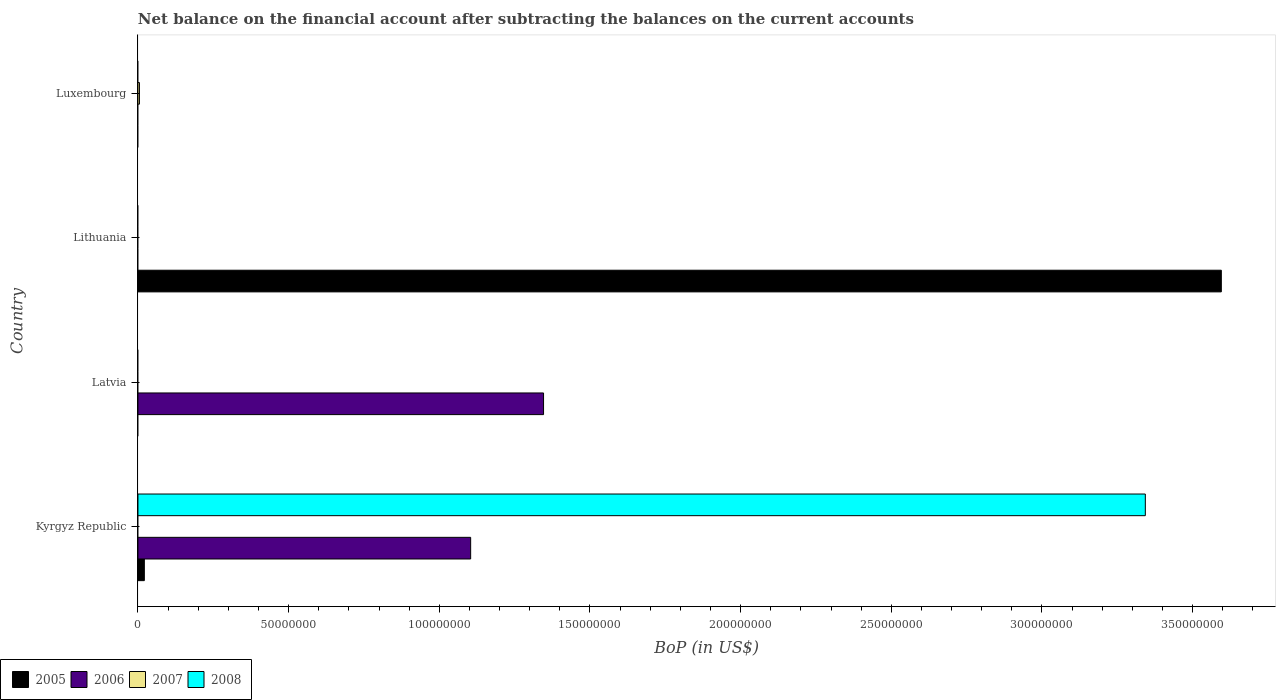How many different coloured bars are there?
Ensure brevity in your answer.  4. Are the number of bars per tick equal to the number of legend labels?
Your answer should be compact. No. How many bars are there on the 3rd tick from the top?
Provide a short and direct response. 1. How many bars are there on the 2nd tick from the bottom?
Make the answer very short. 1. What is the label of the 1st group of bars from the top?
Your answer should be compact. Luxembourg. What is the Balance of Payments in 2008 in Kyrgyz Republic?
Give a very brief answer. 3.34e+08. Across all countries, what is the maximum Balance of Payments in 2008?
Your answer should be compact. 3.34e+08. Across all countries, what is the minimum Balance of Payments in 2006?
Offer a very short reply. 0. In which country was the Balance of Payments in 2005 maximum?
Make the answer very short. Lithuania. What is the total Balance of Payments in 2006 in the graph?
Offer a very short reply. 2.45e+08. What is the difference between the Balance of Payments in 2005 in Kyrgyz Republic and that in Lithuania?
Keep it short and to the point. -3.57e+08. What is the difference between the Balance of Payments in 2008 in Luxembourg and the Balance of Payments in 2005 in Latvia?
Make the answer very short. 0. What is the average Balance of Payments in 2006 per country?
Provide a short and direct response. 6.13e+07. What is the difference between the highest and the lowest Balance of Payments in 2007?
Provide a succinct answer. 4.90e+05. Is it the case that in every country, the sum of the Balance of Payments in 2005 and Balance of Payments in 2008 is greater than the sum of Balance of Payments in 2006 and Balance of Payments in 2007?
Your answer should be very brief. No. How many bars are there?
Ensure brevity in your answer.  6. Are all the bars in the graph horizontal?
Provide a succinct answer. Yes. What is the difference between two consecutive major ticks on the X-axis?
Keep it short and to the point. 5.00e+07. Does the graph contain any zero values?
Keep it short and to the point. Yes. Where does the legend appear in the graph?
Ensure brevity in your answer.  Bottom left. How many legend labels are there?
Your response must be concise. 4. What is the title of the graph?
Offer a terse response. Net balance on the financial account after subtracting the balances on the current accounts. What is the label or title of the X-axis?
Ensure brevity in your answer.  BoP (in US$). What is the label or title of the Y-axis?
Provide a succinct answer. Country. What is the BoP (in US$) in 2005 in Kyrgyz Republic?
Offer a very short reply. 2.12e+06. What is the BoP (in US$) in 2006 in Kyrgyz Republic?
Make the answer very short. 1.10e+08. What is the BoP (in US$) in 2008 in Kyrgyz Republic?
Your response must be concise. 3.34e+08. What is the BoP (in US$) of 2005 in Latvia?
Keep it short and to the point. 0. What is the BoP (in US$) of 2006 in Latvia?
Offer a very short reply. 1.35e+08. What is the BoP (in US$) of 2008 in Latvia?
Your answer should be very brief. 0. What is the BoP (in US$) in 2005 in Lithuania?
Keep it short and to the point. 3.60e+08. What is the BoP (in US$) of 2008 in Lithuania?
Keep it short and to the point. 0. What is the BoP (in US$) in 2005 in Luxembourg?
Your answer should be very brief. 0. What is the BoP (in US$) in 2007 in Luxembourg?
Offer a terse response. 4.90e+05. What is the BoP (in US$) of 2008 in Luxembourg?
Make the answer very short. 0. Across all countries, what is the maximum BoP (in US$) in 2005?
Your answer should be compact. 3.60e+08. Across all countries, what is the maximum BoP (in US$) in 2006?
Provide a short and direct response. 1.35e+08. Across all countries, what is the maximum BoP (in US$) in 2007?
Your answer should be compact. 4.90e+05. Across all countries, what is the maximum BoP (in US$) in 2008?
Offer a very short reply. 3.34e+08. Across all countries, what is the minimum BoP (in US$) of 2006?
Offer a very short reply. 0. Across all countries, what is the minimum BoP (in US$) in 2008?
Your answer should be very brief. 0. What is the total BoP (in US$) of 2005 in the graph?
Give a very brief answer. 3.62e+08. What is the total BoP (in US$) of 2006 in the graph?
Ensure brevity in your answer.  2.45e+08. What is the total BoP (in US$) of 2007 in the graph?
Offer a very short reply. 4.90e+05. What is the total BoP (in US$) of 2008 in the graph?
Give a very brief answer. 3.34e+08. What is the difference between the BoP (in US$) in 2006 in Kyrgyz Republic and that in Latvia?
Your answer should be very brief. -2.42e+07. What is the difference between the BoP (in US$) of 2005 in Kyrgyz Republic and that in Lithuania?
Give a very brief answer. -3.57e+08. What is the difference between the BoP (in US$) in 2005 in Kyrgyz Republic and the BoP (in US$) in 2006 in Latvia?
Give a very brief answer. -1.32e+08. What is the difference between the BoP (in US$) in 2005 in Kyrgyz Republic and the BoP (in US$) in 2007 in Luxembourg?
Make the answer very short. 1.63e+06. What is the difference between the BoP (in US$) in 2006 in Kyrgyz Republic and the BoP (in US$) in 2007 in Luxembourg?
Provide a short and direct response. 1.10e+08. What is the difference between the BoP (in US$) of 2006 in Latvia and the BoP (in US$) of 2007 in Luxembourg?
Your response must be concise. 1.34e+08. What is the difference between the BoP (in US$) of 2005 in Lithuania and the BoP (in US$) of 2007 in Luxembourg?
Your answer should be compact. 3.59e+08. What is the average BoP (in US$) of 2005 per country?
Make the answer very short. 9.04e+07. What is the average BoP (in US$) in 2006 per country?
Your response must be concise. 6.13e+07. What is the average BoP (in US$) of 2007 per country?
Offer a terse response. 1.23e+05. What is the average BoP (in US$) of 2008 per country?
Keep it short and to the point. 8.36e+07. What is the difference between the BoP (in US$) of 2005 and BoP (in US$) of 2006 in Kyrgyz Republic?
Offer a terse response. -1.08e+08. What is the difference between the BoP (in US$) of 2005 and BoP (in US$) of 2008 in Kyrgyz Republic?
Your response must be concise. -3.32e+08. What is the difference between the BoP (in US$) of 2006 and BoP (in US$) of 2008 in Kyrgyz Republic?
Ensure brevity in your answer.  -2.24e+08. What is the ratio of the BoP (in US$) in 2006 in Kyrgyz Republic to that in Latvia?
Make the answer very short. 0.82. What is the ratio of the BoP (in US$) in 2005 in Kyrgyz Republic to that in Lithuania?
Give a very brief answer. 0.01. What is the difference between the highest and the lowest BoP (in US$) in 2005?
Give a very brief answer. 3.60e+08. What is the difference between the highest and the lowest BoP (in US$) of 2006?
Offer a very short reply. 1.35e+08. What is the difference between the highest and the lowest BoP (in US$) in 2007?
Your answer should be compact. 4.90e+05. What is the difference between the highest and the lowest BoP (in US$) in 2008?
Provide a succinct answer. 3.34e+08. 